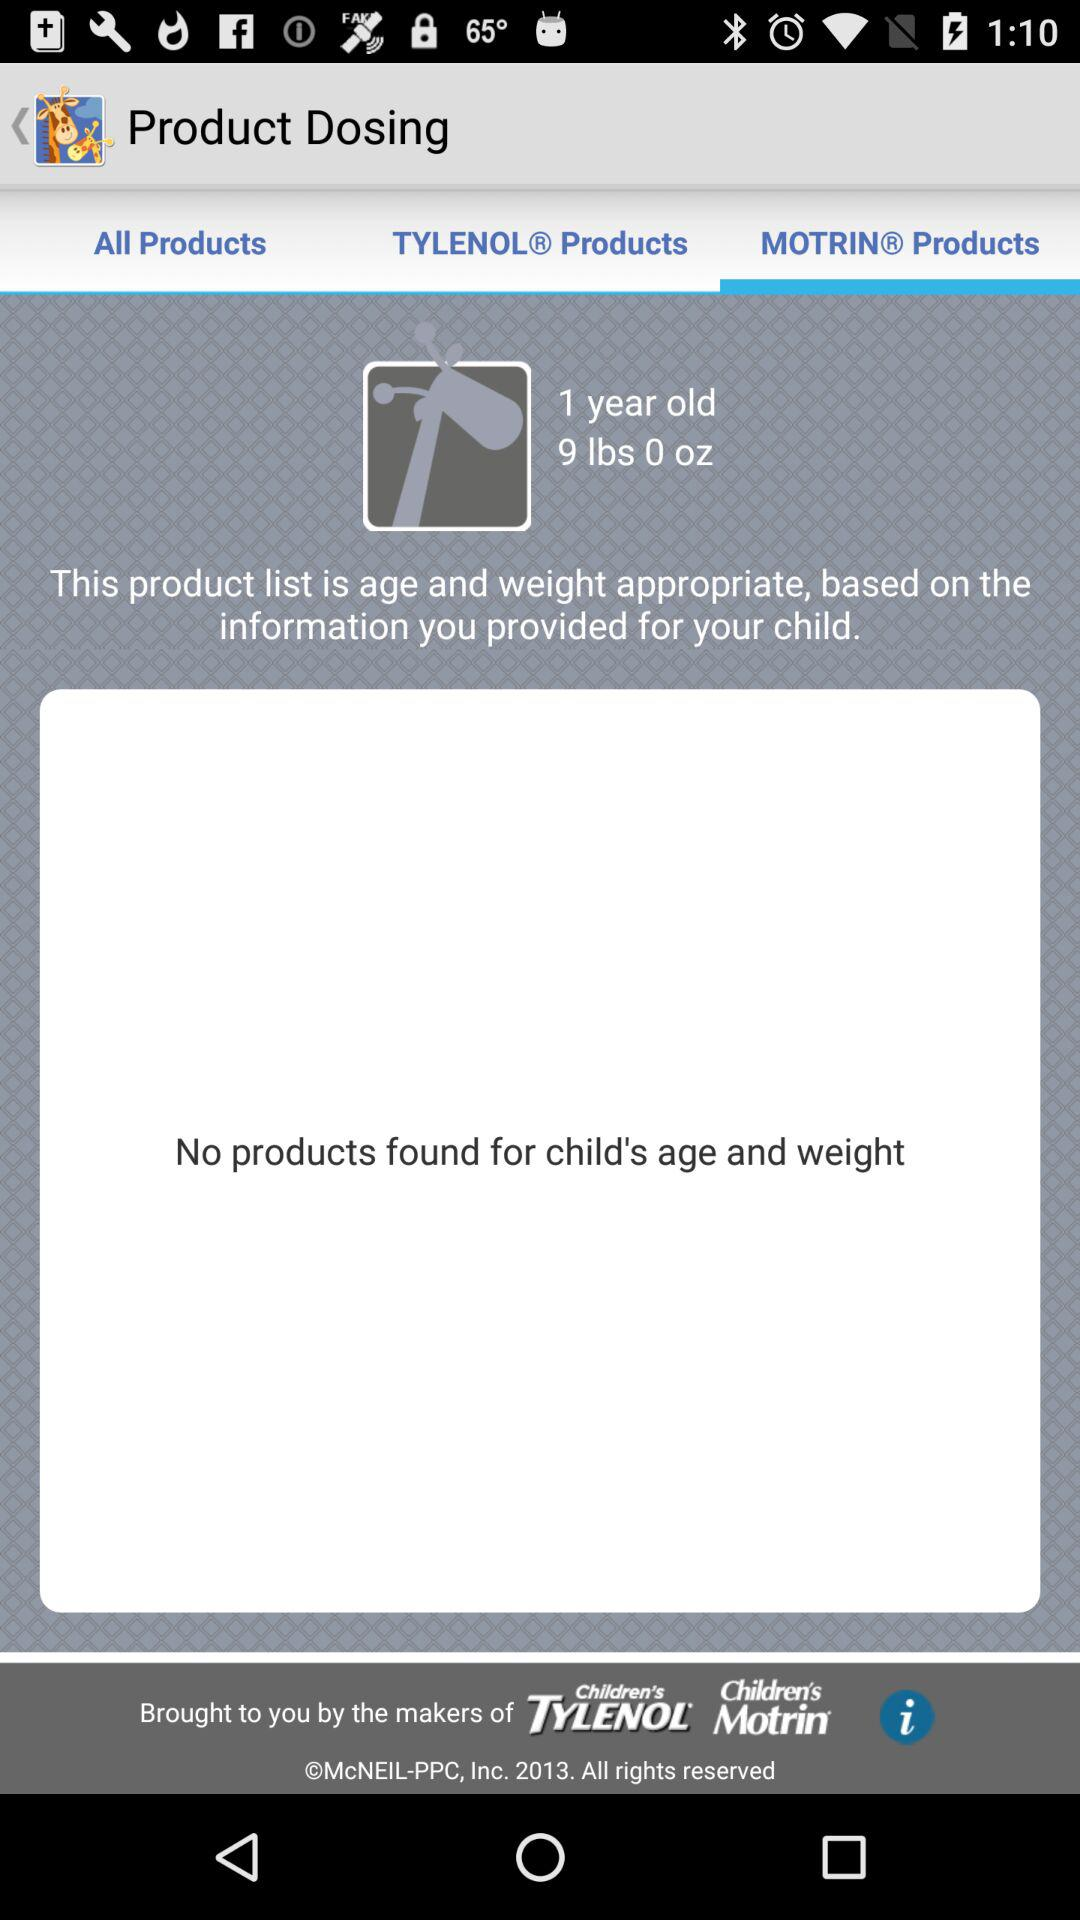What's the weight of the child? The weight of the child is 9 lbs. 